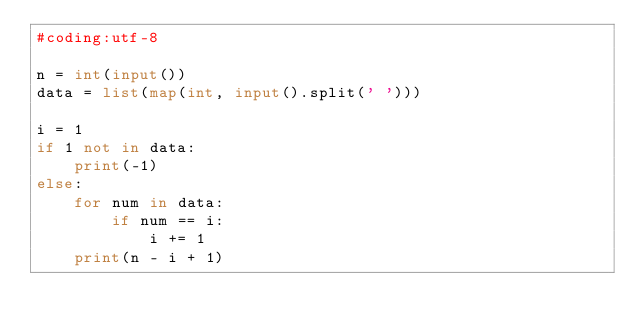<code> <loc_0><loc_0><loc_500><loc_500><_Python_>#coding:utf-8

n = int(input())
data = list(map(int, input().split(' ')))

i = 1
if 1 not in data:
    print(-1)
else:
    for num in data:
        if num == i:
            i += 1
    print(n - i + 1)</code> 